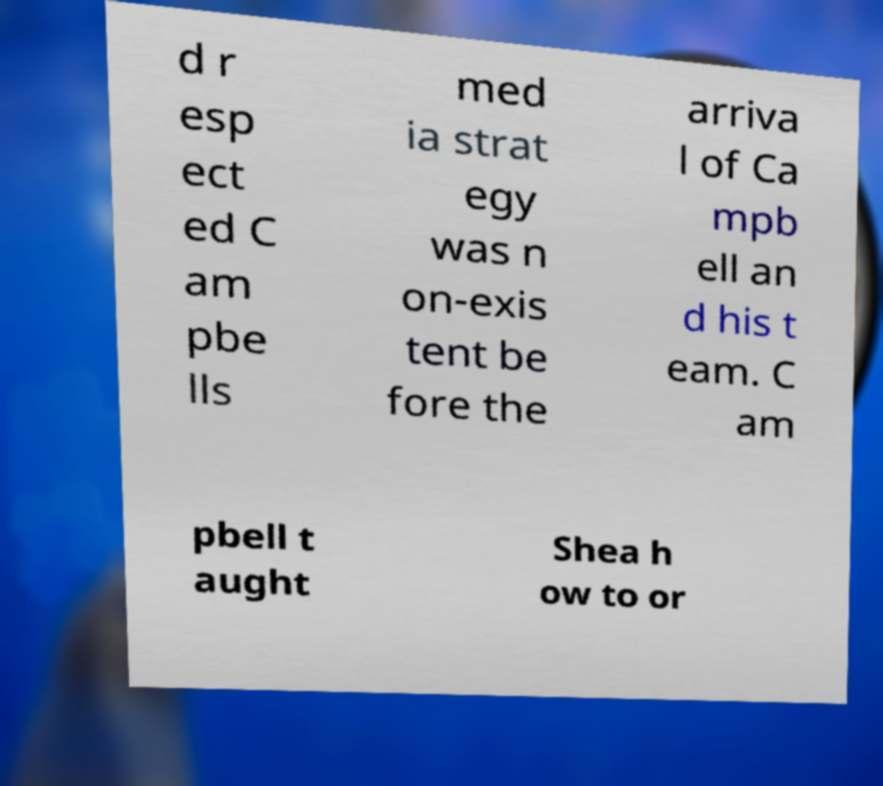Could you extract and type out the text from this image? d r esp ect ed C am pbe lls med ia strat egy was n on-exis tent be fore the arriva l of Ca mpb ell an d his t eam. C am pbell t aught Shea h ow to or 